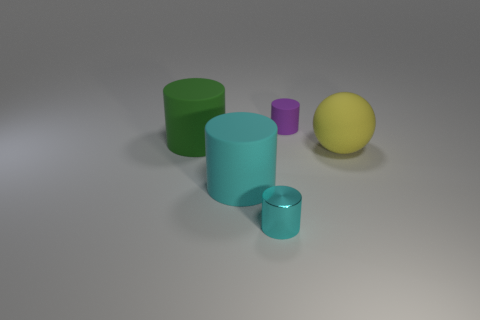The matte thing that is the same color as the metal thing is what shape?
Your answer should be compact. Cylinder. There is a large green matte thing; what shape is it?
Your answer should be compact. Cylinder. Is the number of small metal objects that are behind the purple object less than the number of tiny purple rubber objects?
Give a very brief answer. Yes. Are there any cyan metal things of the same shape as the purple object?
Keep it short and to the point. Yes. The other object that is the same size as the purple rubber thing is what shape?
Keep it short and to the point. Cylinder. What number of things are either big spheres or rubber things?
Ensure brevity in your answer.  4. Are any cyan metal cylinders visible?
Offer a very short reply. Yes. Is the number of tiny green spheres less than the number of tiny matte cylinders?
Provide a succinct answer. Yes. Are there any yellow metal cubes of the same size as the yellow object?
Provide a short and direct response. No. Do the yellow object and the small thing on the right side of the small cyan metal cylinder have the same shape?
Your answer should be very brief. No. 